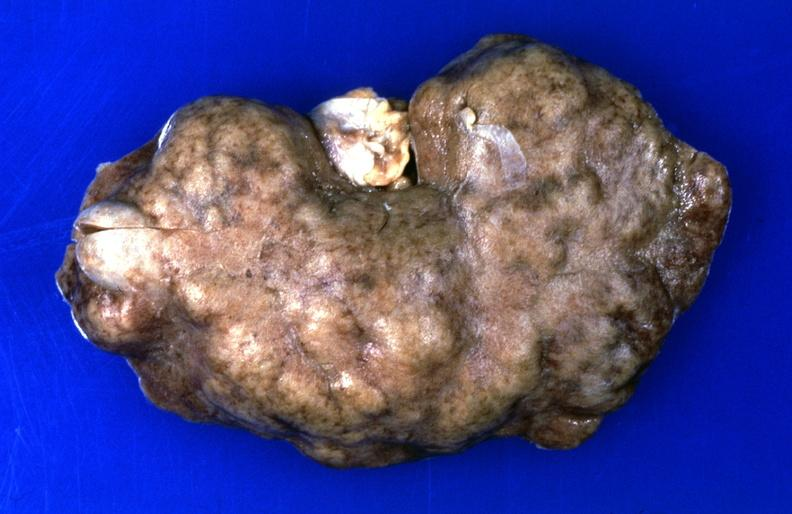does mesothelioma show kidney, hemochromatosis, chronic scarring?
Answer the question using a single word or phrase. No 